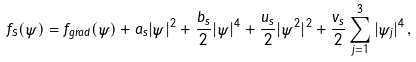Convert formula to latex. <formula><loc_0><loc_0><loc_500><loc_500>f _ { S } ( \psi ) = f _ { g r a d } ( \psi ) + a _ { s } | \psi | ^ { 2 } + \frac { b _ { s } } { 2 } | \psi | ^ { 4 } + \frac { u _ { s } } { 2 } | \psi ^ { 2 } | ^ { 2 } + \frac { v _ { s } } { 2 } \sum _ { j = 1 } ^ { 3 } | \psi _ { j } | ^ { 4 } \, ,</formula> 